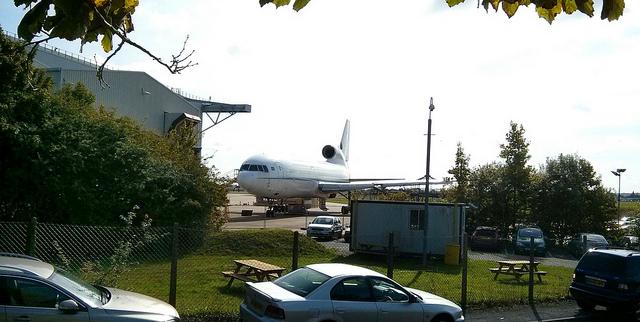How many buildings are visible?
Concise answer only. 2. Where are the cars parked?
Concise answer only. Street. What is visible in the center of the picture?
Be succinct. Airplane. 